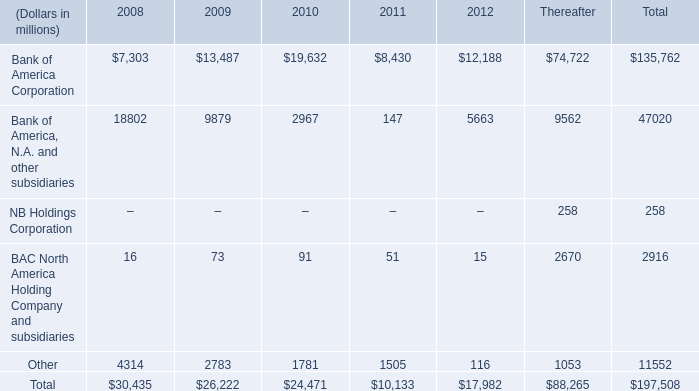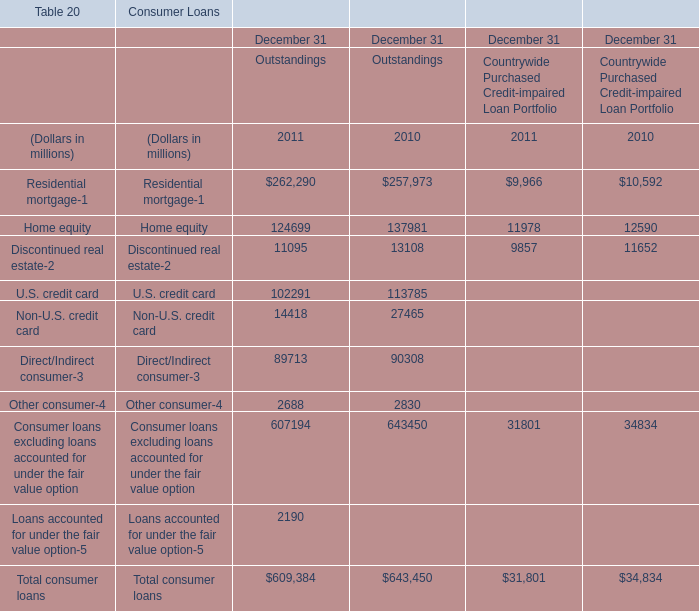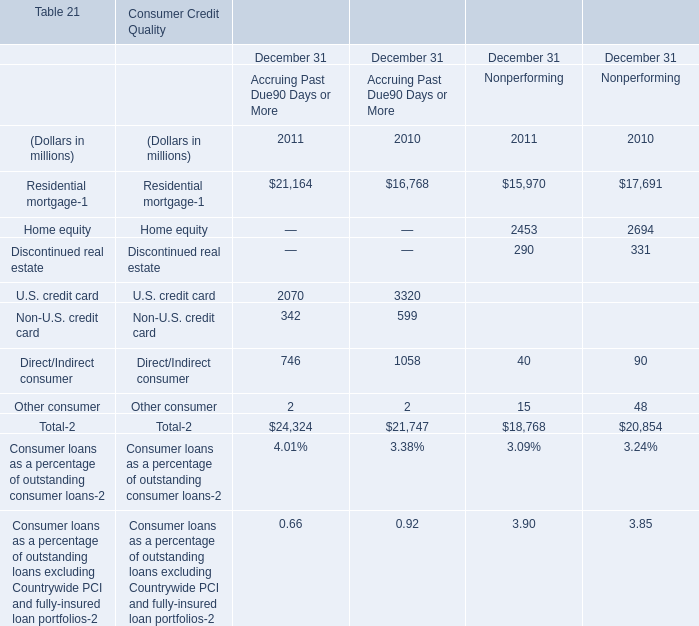What is the average amount of Bank of America, N.A. and other subsidiaries of 2010, and Discontinued real estate of Consumer Loans December 31 Outstandings 2011 ? 
Computations: ((2967.0 + 11095.0) / 2)
Answer: 7031.0. 